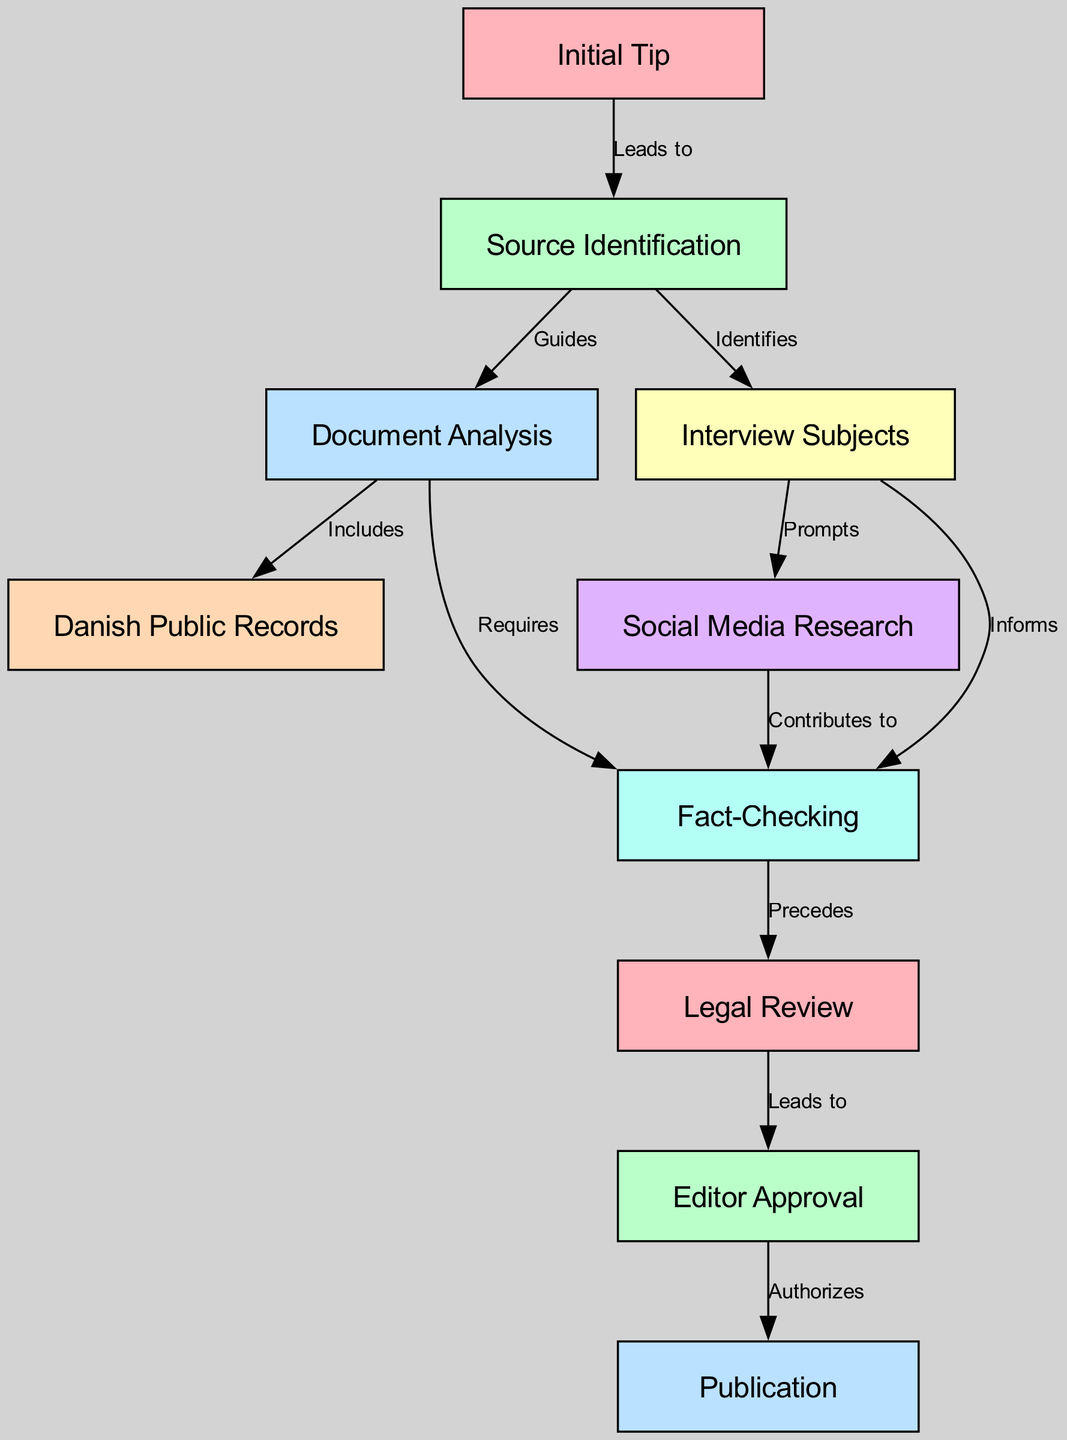What is the first step in the investigative journalism workflow? The diagram shows that the first step in the workflow is "Initial Tip," which is the starting node from where the process begins.
Answer: Initial Tip How many nodes are present in the diagram? By counting the nodes listed in the diagram, there are a total of 10 nodes that represent various steps in the investigative journalism workflow.
Answer: 10 What relationship exists between "Source Identification" and "Document Analysis"? The diagram indicates that "Source Identification" guides the process towards "Document Analysis," establishing a direct relationship between these two nodes.
Answer: Guides Which step precedes "Legal Review"? The diagram shows that "Fact-Checking" comes before "Legal Review," indicating a sequential flow where fact-checking is necessary prior to legal examination.
Answer: Fact-Checking How many edges connect to "Fact-Checking"? From the diagram, it can be observed that "Fact-Checking" has three incoming edges, showing that it is informed by "Document Analysis," "Interview Subjects," and "Social Media Research."
Answer: 3 Which node is the final step before "Publication"? The diagram indicates that "Editor Approval" is the step that directly precedes "Publication," thus finalizing the review process before dissemination.
Answer: Editor Approval What contributes to "Fact-Checking"? The relationships in the diagram denote that both "Document Analysis" and "Social Media Research," as well as "Interview Subjects," contribute to the fact-checking process.
Answer: Document Analysis, Social Media Research, Interview Subjects What does "Interview Subjects" prompt in the workflow? The diagram specifies that "Interview Subjects" prompts the step of "Social Media Research," indicating a flow of information from interviews leading to social media investigation.
Answer: Social Media Research How does "Document Analysis" relate to "Danish Public Records"? According to the diagram, "Document Analysis" includes "Danish Public Records," indicating that these records are an essential part of analyzing documents.
Answer: Includes 